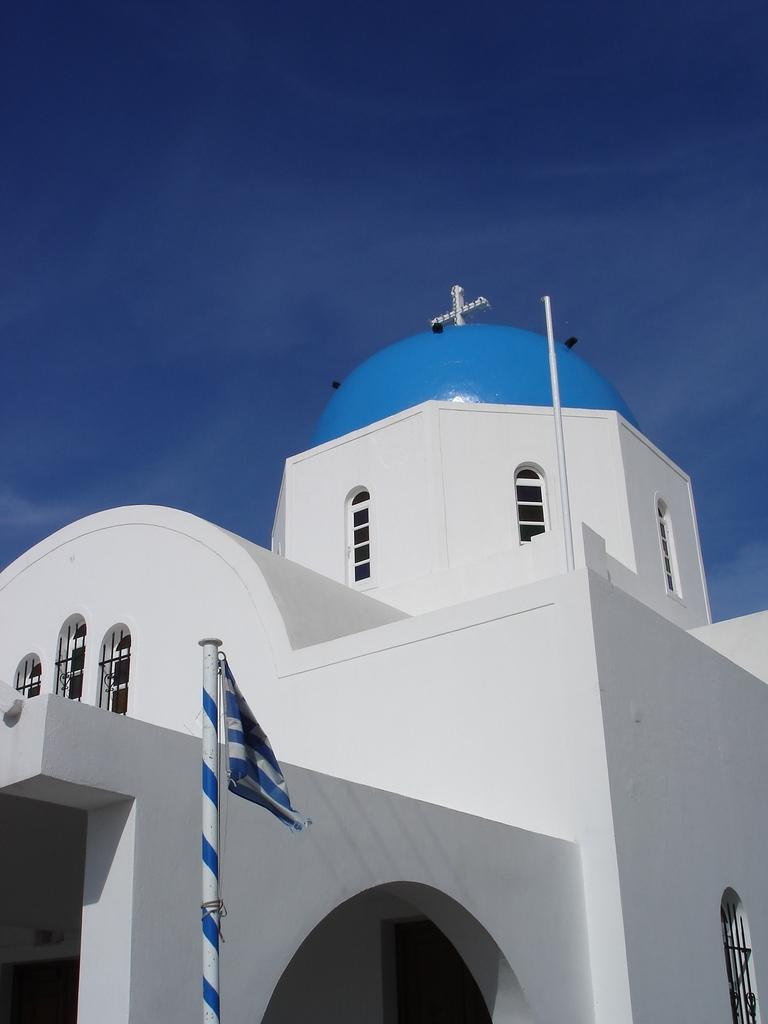What is located in the foreground of the picture? There is a flag in the foreground of the picture. What structure is in the middle of the picture? There is a church in the middle of the picture. What is visible at the top of the picture? The sky is visible at the top of the picture. What type of leather is being used to make the road in the image? There is no road present in the image, and therefore no leather can be associated with it. Can you tell me the name of the lawyer standing next to the church in the image? There are no people, including lawyers, present in the image. 